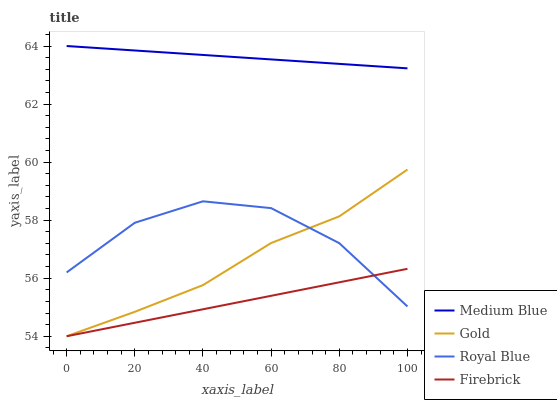Does Firebrick have the minimum area under the curve?
Answer yes or no. Yes. Does Medium Blue have the maximum area under the curve?
Answer yes or no. Yes. Does Medium Blue have the minimum area under the curve?
Answer yes or no. No. Does Firebrick have the maximum area under the curve?
Answer yes or no. No. Is Medium Blue the smoothest?
Answer yes or no. Yes. Is Royal Blue the roughest?
Answer yes or no. Yes. Is Firebrick the smoothest?
Answer yes or no. No. Is Firebrick the roughest?
Answer yes or no. No. Does Firebrick have the lowest value?
Answer yes or no. Yes. Does Medium Blue have the lowest value?
Answer yes or no. No. Does Medium Blue have the highest value?
Answer yes or no. Yes. Does Firebrick have the highest value?
Answer yes or no. No. Is Royal Blue less than Medium Blue?
Answer yes or no. Yes. Is Medium Blue greater than Gold?
Answer yes or no. Yes. Does Royal Blue intersect Firebrick?
Answer yes or no. Yes. Is Royal Blue less than Firebrick?
Answer yes or no. No. Is Royal Blue greater than Firebrick?
Answer yes or no. No. Does Royal Blue intersect Medium Blue?
Answer yes or no. No. 